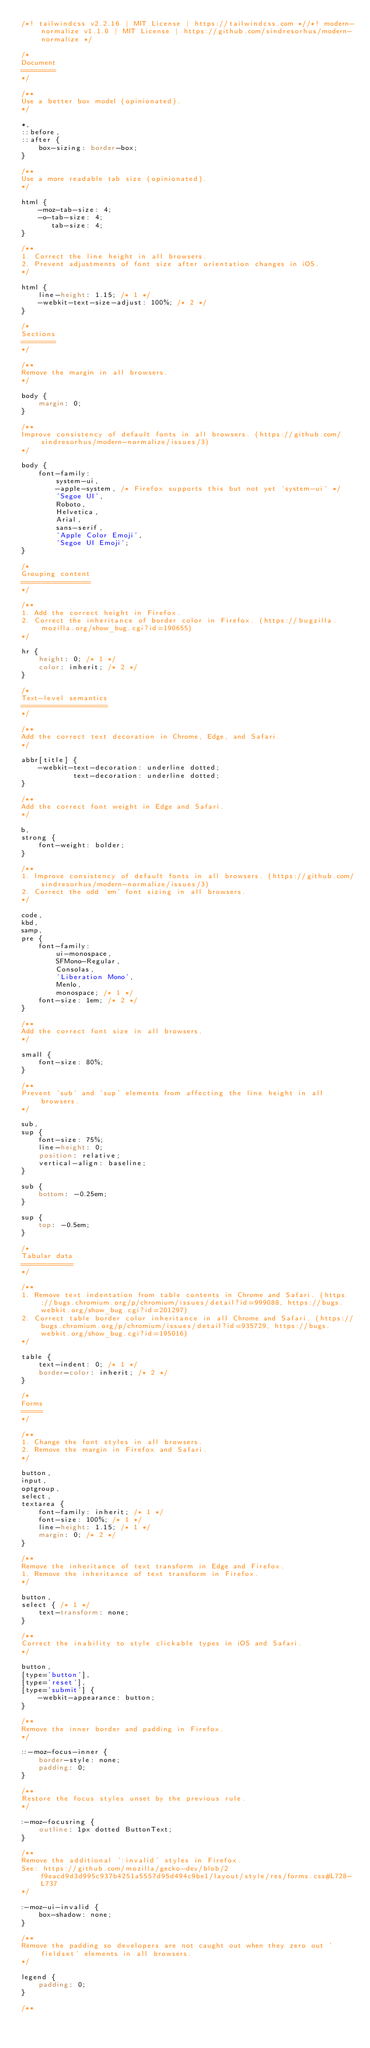<code> <loc_0><loc_0><loc_500><loc_500><_CSS_>/*! tailwindcss v2.2.16 | MIT License | https://tailwindcss.com *//*! modern-normalize v1.1.0 | MIT License | https://github.com/sindresorhus/modern-normalize */

/*
Document
========
*/

/**
Use a better box model (opinionated).
*/

*,
::before,
::after {
	box-sizing: border-box;
}

/**
Use a more readable tab size (opinionated).
*/

html {
	-moz-tab-size: 4;
	-o-tab-size: 4;
	   tab-size: 4;
}

/**
1. Correct the line height in all browsers.
2. Prevent adjustments of font size after orientation changes in iOS.
*/

html {
	line-height: 1.15; /* 1 */
	-webkit-text-size-adjust: 100%; /* 2 */
}

/*
Sections
========
*/

/**
Remove the margin in all browsers.
*/

body {
	margin: 0;
}

/**
Improve consistency of default fonts in all browsers. (https://github.com/sindresorhus/modern-normalize/issues/3)
*/

body {
	font-family:
		system-ui,
		-apple-system, /* Firefox supports this but not yet `system-ui` */
		'Segoe UI',
		Roboto,
		Helvetica,
		Arial,
		sans-serif,
		'Apple Color Emoji',
		'Segoe UI Emoji';
}

/*
Grouping content
================
*/

/**
1. Add the correct height in Firefox.
2. Correct the inheritance of border color in Firefox. (https://bugzilla.mozilla.org/show_bug.cgi?id=190655)
*/

hr {
	height: 0; /* 1 */
	color: inherit; /* 2 */
}

/*
Text-level semantics
====================
*/

/**
Add the correct text decoration in Chrome, Edge, and Safari.
*/

abbr[title] {
	-webkit-text-decoration: underline dotted;
	        text-decoration: underline dotted;
}

/**
Add the correct font weight in Edge and Safari.
*/

b,
strong {
	font-weight: bolder;
}

/**
1. Improve consistency of default fonts in all browsers. (https://github.com/sindresorhus/modern-normalize/issues/3)
2. Correct the odd 'em' font sizing in all browsers.
*/

code,
kbd,
samp,
pre {
	font-family:
		ui-monospace,
		SFMono-Regular,
		Consolas,
		'Liberation Mono',
		Menlo,
		monospace; /* 1 */
	font-size: 1em; /* 2 */
}

/**
Add the correct font size in all browsers.
*/

small {
	font-size: 80%;
}

/**
Prevent 'sub' and 'sup' elements from affecting the line height in all browsers.
*/

sub,
sup {
	font-size: 75%;
	line-height: 0;
	position: relative;
	vertical-align: baseline;
}

sub {
	bottom: -0.25em;
}

sup {
	top: -0.5em;
}

/*
Tabular data
============
*/

/**
1. Remove text indentation from table contents in Chrome and Safari. (https://bugs.chromium.org/p/chromium/issues/detail?id=999088, https://bugs.webkit.org/show_bug.cgi?id=201297)
2. Correct table border color inheritance in all Chrome and Safari. (https://bugs.chromium.org/p/chromium/issues/detail?id=935729, https://bugs.webkit.org/show_bug.cgi?id=195016)
*/

table {
	text-indent: 0; /* 1 */
	border-color: inherit; /* 2 */
}

/*
Forms
=====
*/

/**
1. Change the font styles in all browsers.
2. Remove the margin in Firefox and Safari.
*/

button,
input,
optgroup,
select,
textarea {
	font-family: inherit; /* 1 */
	font-size: 100%; /* 1 */
	line-height: 1.15; /* 1 */
	margin: 0; /* 2 */
}

/**
Remove the inheritance of text transform in Edge and Firefox.
1. Remove the inheritance of text transform in Firefox.
*/

button,
select { /* 1 */
	text-transform: none;
}

/**
Correct the inability to style clickable types in iOS and Safari.
*/

button,
[type='button'],
[type='reset'],
[type='submit'] {
	-webkit-appearance: button;
}

/**
Remove the inner border and padding in Firefox.
*/

::-moz-focus-inner {
	border-style: none;
	padding: 0;
}

/**
Restore the focus styles unset by the previous rule.
*/

:-moz-focusring {
	outline: 1px dotted ButtonText;
}

/**
Remove the additional ':invalid' styles in Firefox.
See: https://github.com/mozilla/gecko-dev/blob/2f9eacd9d3d995c937b4251a5557d95d494c9be1/layout/style/res/forms.css#L728-L737
*/

:-moz-ui-invalid {
	box-shadow: none;
}

/**
Remove the padding so developers are not caught out when they zero out 'fieldset' elements in all browsers.
*/

legend {
	padding: 0;
}

/**</code> 